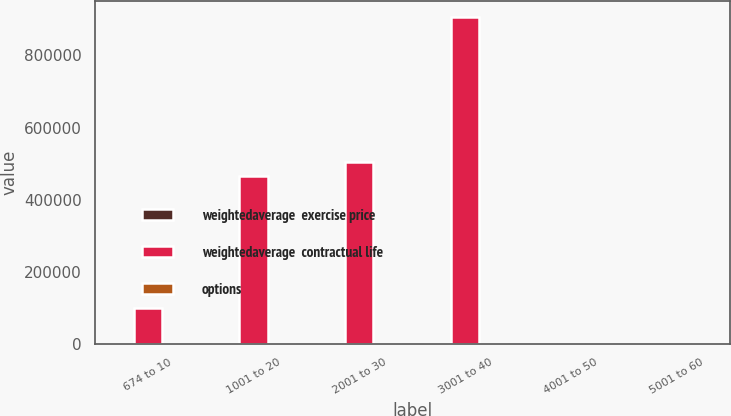<chart> <loc_0><loc_0><loc_500><loc_500><stacked_bar_chart><ecel><fcel>674 to 10<fcel>1001 to 20<fcel>2001 to 30<fcel>3001 to 40<fcel>4001 to 50<fcel>5001 to 60<nl><fcel>weightedaverage  exercise price<fcel>0.9<fcel>2.8<fcel>4.2<fcel>5.3<fcel>7.3<fcel>8.2<nl><fcel>weightedaverage  contractual life<fcel>100351<fcel>466435<fcel>505730<fcel>906905<fcel>19.565<fcel>19.565<nl><fcel>options<fcel>8.4<fcel>13.2<fcel>25.93<fcel>34.71<fcel>42.19<fcel>52.3<nl></chart> 